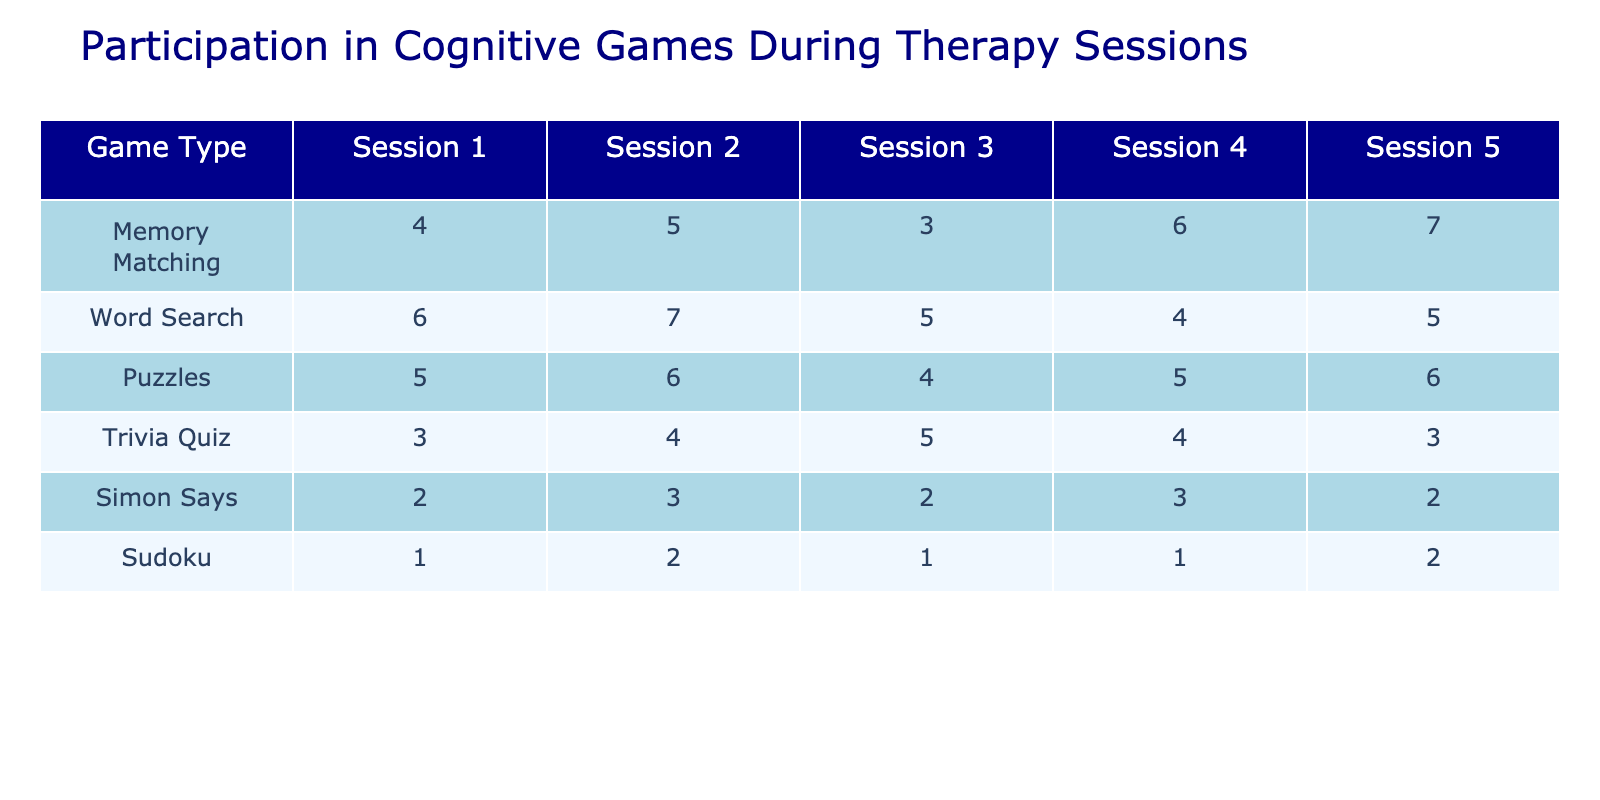What was the total participation in Memory Matching across all sessions? The participation in Memory Matching is 4 + 5 + 3 + 6 + 7 = 25 across all sessions.
Answer: 25 How many times was Sudoku played in Session 3? From the table, the participation in Sudoku for Session 3 is clearly indicated as 1.
Answer: 1 What is the game that had the highest participation in Session 2? Looking at the values for Session 2, Memory Matching (5), Word Search (7), Puzzles (6), Trivia Quiz (4), Simon Says (3), and Sudoku (2), Word Search has the highest value at 7.
Answer: Word Search What is the average participation in Trivia Quiz for all sessions? The total participation for Trivia Quiz is 3 + 4 + 5 + 4 + 3 = 19, and there are 5 sessions, so the average is 19 / 5 = 3.8.
Answer: 3.8 Did more people participate in Simon Says or Sudoku across all sessions? The total participation for Simon Says is 2 + 3 + 2 + 3 + 2 = 12 and for Sudoku is 1 + 2 + 1 + 1 + 2 = 7. Since 12 > 7, more people participated in Simon Says.
Answer: Yes Which game had the least participation in Session 5? The participation numbers in Session 5 are 7 (Memory Matching), 5 (Word Search), 6 (Puzzles), 3 (Trivia Quiz), 2 (Simon Says), and 2 (Sudoku). Both Simon Says and Sudoku have the least value of 2.
Answer: Simon Says and Sudoku What is the overall trend in participation for Puzzles from Session 1 to Session 5? The participation in Puzzles across the sessions is 5, 6, 4, 5, and 6. Analyzing these values: it increased from Session 1 to 2, decreased in Session 3, then increased again in Sessions 4 and 5, suggesting fluctuations in participation.
Answer: Fluctuating What is the total number of sessions where Memory Matching had more than 5 participants? Looking at the values for Memory Matching: 4, 5, 3, 6, and 7, it had more than 5 participants in Sessions 4 (6) and 5 (7), totaling 2 sessions.
Answer: 2 In which session did Word Search see the most significant drop in participation? The participation in Word Search across sessions is 6, 7, 5, 4, and 5, which shows a drop from 7 in Session 2 to 4 in Session 4, a drop of 3. This is the most significant drop in participation.
Answer: Session 4 